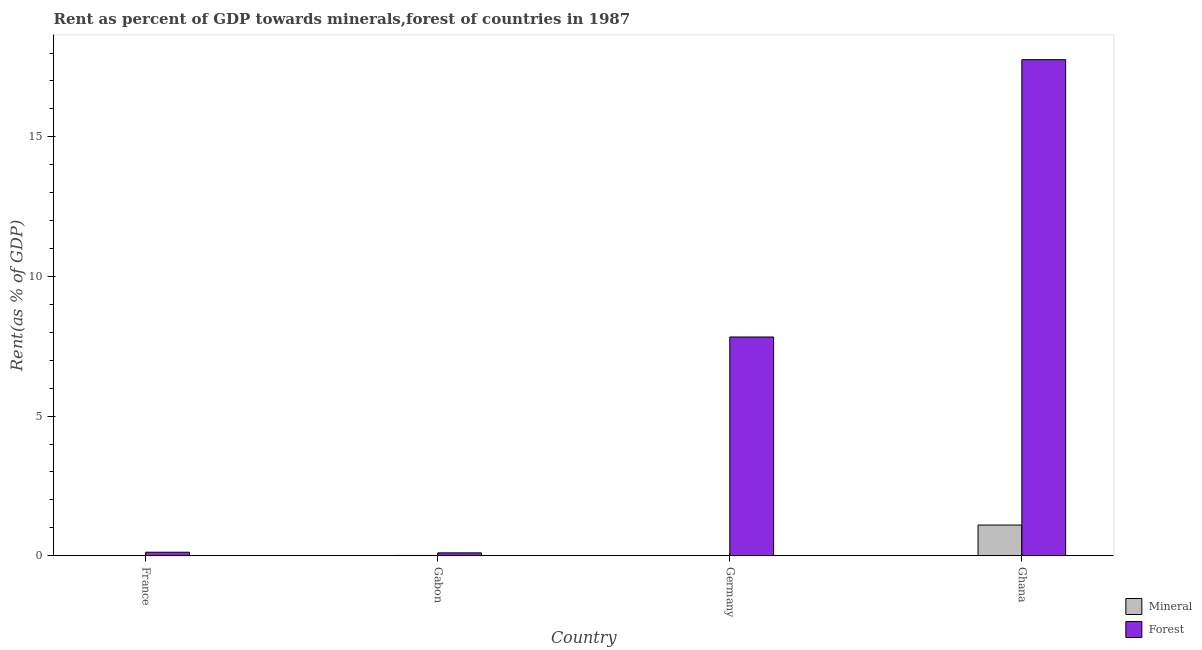How many different coloured bars are there?
Your response must be concise. 2. Are the number of bars on each tick of the X-axis equal?
Give a very brief answer. Yes. How many bars are there on the 3rd tick from the right?
Provide a succinct answer. 2. What is the mineral rent in France?
Offer a terse response. 0. Across all countries, what is the maximum mineral rent?
Offer a very short reply. 1.1. Across all countries, what is the minimum mineral rent?
Offer a very short reply. 0. In which country was the forest rent minimum?
Ensure brevity in your answer.  Gabon. What is the total forest rent in the graph?
Keep it short and to the point. 25.83. What is the difference between the mineral rent in France and that in Germany?
Provide a succinct answer. 0. What is the difference between the forest rent in Germany and the mineral rent in France?
Keep it short and to the point. 7.83. What is the average mineral rent per country?
Offer a terse response. 0.28. What is the difference between the mineral rent and forest rent in Ghana?
Make the answer very short. -16.66. In how many countries, is the mineral rent greater than 17 %?
Make the answer very short. 0. What is the ratio of the mineral rent in Gabon to that in Germany?
Give a very brief answer. 27.45. What is the difference between the highest and the second highest forest rent?
Offer a terse response. 9.93. What is the difference between the highest and the lowest mineral rent?
Make the answer very short. 1.1. What does the 2nd bar from the left in Germany represents?
Your response must be concise. Forest. What does the 2nd bar from the right in France represents?
Give a very brief answer. Mineral. Are all the bars in the graph horizontal?
Offer a very short reply. No. How many countries are there in the graph?
Ensure brevity in your answer.  4. What is the difference between two consecutive major ticks on the Y-axis?
Make the answer very short. 5. Does the graph contain grids?
Offer a very short reply. No. Where does the legend appear in the graph?
Make the answer very short. Bottom right. How are the legend labels stacked?
Your answer should be compact. Vertical. What is the title of the graph?
Your answer should be compact. Rent as percent of GDP towards minerals,forest of countries in 1987. Does "Diarrhea" appear as one of the legend labels in the graph?
Provide a succinct answer. No. What is the label or title of the X-axis?
Your answer should be very brief. Country. What is the label or title of the Y-axis?
Provide a succinct answer. Rent(as % of GDP). What is the Rent(as % of GDP) in Mineral in France?
Make the answer very short. 0. What is the Rent(as % of GDP) of Forest in France?
Make the answer very short. 0.13. What is the Rent(as % of GDP) in Mineral in Gabon?
Give a very brief answer. 0.01. What is the Rent(as % of GDP) of Forest in Gabon?
Provide a succinct answer. 0.11. What is the Rent(as % of GDP) in Mineral in Germany?
Give a very brief answer. 0. What is the Rent(as % of GDP) in Forest in Germany?
Your answer should be very brief. 7.83. What is the Rent(as % of GDP) of Mineral in Ghana?
Your answer should be compact. 1.1. What is the Rent(as % of GDP) in Forest in Ghana?
Your response must be concise. 17.76. Across all countries, what is the maximum Rent(as % of GDP) in Mineral?
Your answer should be very brief. 1.1. Across all countries, what is the maximum Rent(as % of GDP) in Forest?
Offer a terse response. 17.76. Across all countries, what is the minimum Rent(as % of GDP) in Mineral?
Your answer should be compact. 0. Across all countries, what is the minimum Rent(as % of GDP) in Forest?
Your answer should be compact. 0.11. What is the total Rent(as % of GDP) in Mineral in the graph?
Ensure brevity in your answer.  1.12. What is the total Rent(as % of GDP) of Forest in the graph?
Give a very brief answer. 25.83. What is the difference between the Rent(as % of GDP) in Mineral in France and that in Gabon?
Provide a short and direct response. -0.01. What is the difference between the Rent(as % of GDP) in Forest in France and that in Gabon?
Offer a very short reply. 0.02. What is the difference between the Rent(as % of GDP) in Mineral in France and that in Germany?
Your answer should be compact. 0. What is the difference between the Rent(as % of GDP) in Forest in France and that in Germany?
Offer a terse response. -7.71. What is the difference between the Rent(as % of GDP) in Mineral in France and that in Ghana?
Offer a very short reply. -1.1. What is the difference between the Rent(as % of GDP) in Forest in France and that in Ghana?
Provide a succinct answer. -17.63. What is the difference between the Rent(as % of GDP) in Mineral in Gabon and that in Germany?
Your response must be concise. 0.01. What is the difference between the Rent(as % of GDP) in Forest in Gabon and that in Germany?
Provide a succinct answer. -7.73. What is the difference between the Rent(as % of GDP) of Mineral in Gabon and that in Ghana?
Ensure brevity in your answer.  -1.09. What is the difference between the Rent(as % of GDP) in Forest in Gabon and that in Ghana?
Make the answer very short. -17.66. What is the difference between the Rent(as % of GDP) in Mineral in Germany and that in Ghana?
Give a very brief answer. -1.1. What is the difference between the Rent(as % of GDP) in Forest in Germany and that in Ghana?
Keep it short and to the point. -9.93. What is the difference between the Rent(as % of GDP) in Mineral in France and the Rent(as % of GDP) in Forest in Gabon?
Ensure brevity in your answer.  -0.1. What is the difference between the Rent(as % of GDP) of Mineral in France and the Rent(as % of GDP) of Forest in Germany?
Provide a succinct answer. -7.83. What is the difference between the Rent(as % of GDP) in Mineral in France and the Rent(as % of GDP) in Forest in Ghana?
Keep it short and to the point. -17.76. What is the difference between the Rent(as % of GDP) of Mineral in Gabon and the Rent(as % of GDP) of Forest in Germany?
Make the answer very short. -7.82. What is the difference between the Rent(as % of GDP) in Mineral in Gabon and the Rent(as % of GDP) in Forest in Ghana?
Your response must be concise. -17.75. What is the difference between the Rent(as % of GDP) in Mineral in Germany and the Rent(as % of GDP) in Forest in Ghana?
Offer a terse response. -17.76. What is the average Rent(as % of GDP) in Mineral per country?
Keep it short and to the point. 0.28. What is the average Rent(as % of GDP) of Forest per country?
Make the answer very short. 6.46. What is the difference between the Rent(as % of GDP) of Mineral and Rent(as % of GDP) of Forest in France?
Keep it short and to the point. -0.12. What is the difference between the Rent(as % of GDP) in Mineral and Rent(as % of GDP) in Forest in Gabon?
Provide a short and direct response. -0.09. What is the difference between the Rent(as % of GDP) of Mineral and Rent(as % of GDP) of Forest in Germany?
Give a very brief answer. -7.83. What is the difference between the Rent(as % of GDP) of Mineral and Rent(as % of GDP) of Forest in Ghana?
Offer a very short reply. -16.66. What is the ratio of the Rent(as % of GDP) in Mineral in France to that in Gabon?
Your answer should be very brief. 0.26. What is the ratio of the Rent(as % of GDP) in Forest in France to that in Gabon?
Provide a succinct answer. 1.21. What is the ratio of the Rent(as % of GDP) of Mineral in France to that in Germany?
Make the answer very short. 7.22. What is the ratio of the Rent(as % of GDP) of Forest in France to that in Germany?
Your response must be concise. 0.02. What is the ratio of the Rent(as % of GDP) in Mineral in France to that in Ghana?
Provide a short and direct response. 0. What is the ratio of the Rent(as % of GDP) of Forest in France to that in Ghana?
Give a very brief answer. 0.01. What is the ratio of the Rent(as % of GDP) in Mineral in Gabon to that in Germany?
Your response must be concise. 27.45. What is the ratio of the Rent(as % of GDP) of Forest in Gabon to that in Germany?
Provide a short and direct response. 0.01. What is the ratio of the Rent(as % of GDP) in Mineral in Gabon to that in Ghana?
Your answer should be very brief. 0.01. What is the ratio of the Rent(as % of GDP) in Forest in Gabon to that in Ghana?
Provide a short and direct response. 0.01. What is the ratio of the Rent(as % of GDP) of Mineral in Germany to that in Ghana?
Your answer should be compact. 0. What is the ratio of the Rent(as % of GDP) in Forest in Germany to that in Ghana?
Offer a terse response. 0.44. What is the difference between the highest and the second highest Rent(as % of GDP) in Mineral?
Make the answer very short. 1.09. What is the difference between the highest and the second highest Rent(as % of GDP) of Forest?
Your answer should be compact. 9.93. What is the difference between the highest and the lowest Rent(as % of GDP) in Mineral?
Your answer should be compact. 1.1. What is the difference between the highest and the lowest Rent(as % of GDP) in Forest?
Your answer should be compact. 17.66. 